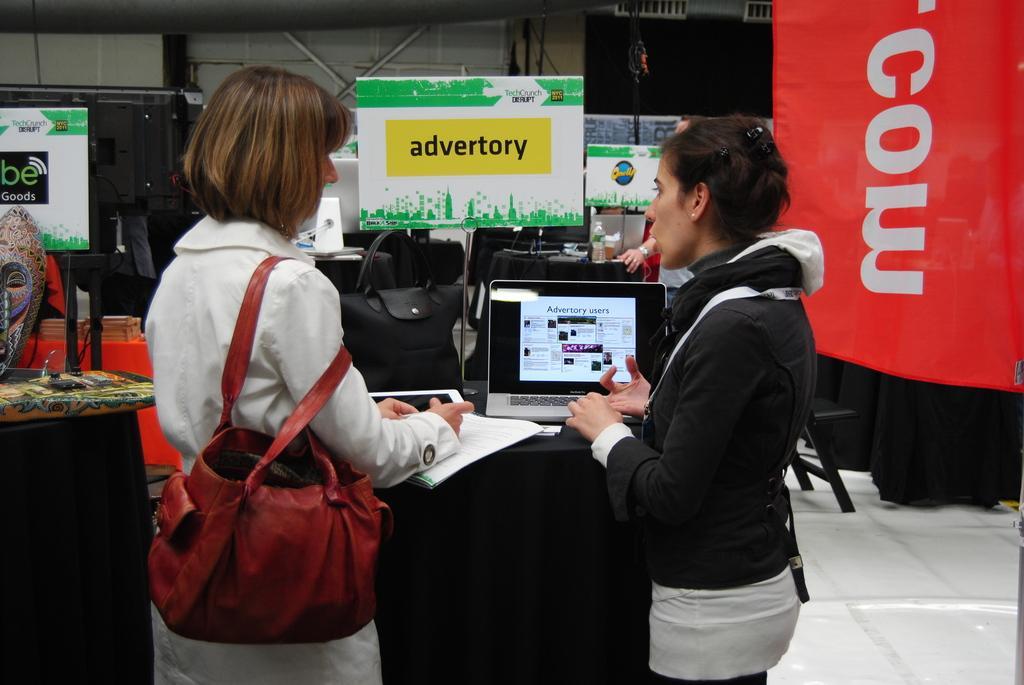Please provide a concise description of this image. Here we can see a couple of woman standing in front of a table with the laptop on it and the woman on the left side holding a handbag there are other handbags present on the table and we can see banners here and there 